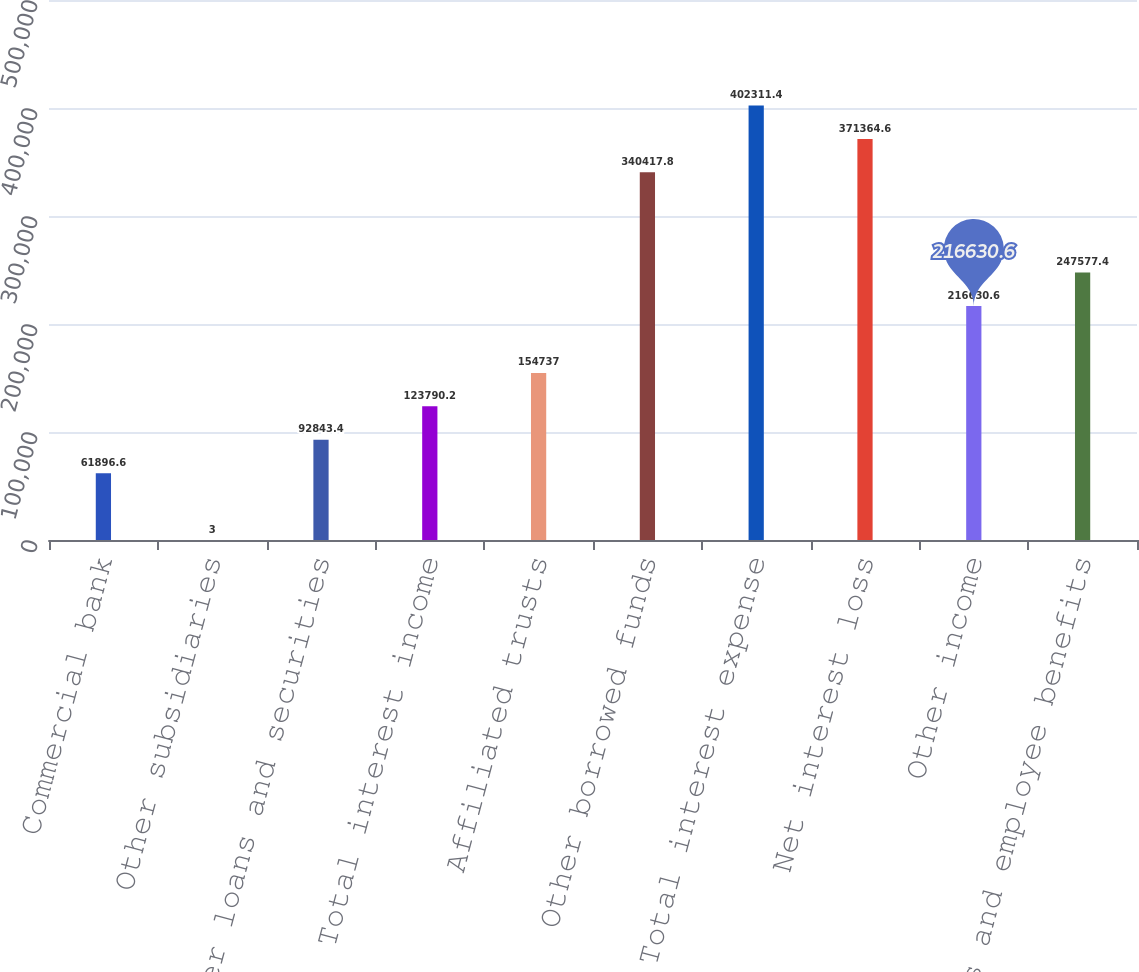Convert chart. <chart><loc_0><loc_0><loc_500><loc_500><bar_chart><fcel>Commercial bank<fcel>Other subsidiaries<fcel>Other loans and securities<fcel>Total interest income<fcel>Affiliated trusts<fcel>Other borrowed funds<fcel>Total interest expense<fcel>Net interest loss<fcel>Other income<fcel>Salaries and employee benefits<nl><fcel>61896.6<fcel>3<fcel>92843.4<fcel>123790<fcel>154737<fcel>340418<fcel>402311<fcel>371365<fcel>216631<fcel>247577<nl></chart> 